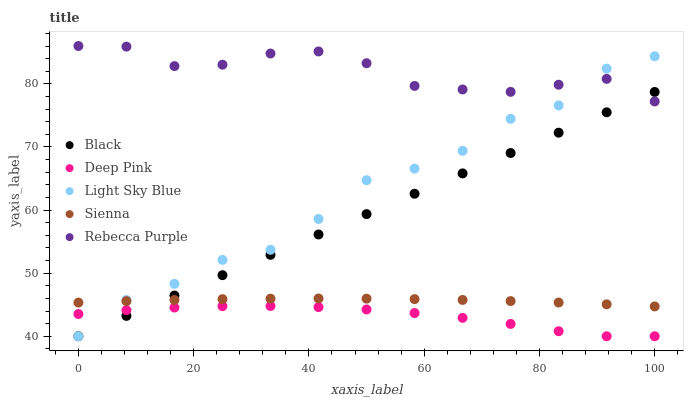Does Deep Pink have the minimum area under the curve?
Answer yes or no. Yes. Does Rebecca Purple have the maximum area under the curve?
Answer yes or no. Yes. Does Black have the minimum area under the curve?
Answer yes or no. No. Does Black have the maximum area under the curve?
Answer yes or no. No. Is Black the smoothest?
Answer yes or no. Yes. Is Light Sky Blue the roughest?
Answer yes or no. Yes. Is Deep Pink the smoothest?
Answer yes or no. No. Is Deep Pink the roughest?
Answer yes or no. No. Does Deep Pink have the lowest value?
Answer yes or no. Yes. Does Rebecca Purple have the lowest value?
Answer yes or no. No. Does Rebecca Purple have the highest value?
Answer yes or no. Yes. Does Black have the highest value?
Answer yes or no. No. Is Deep Pink less than Sienna?
Answer yes or no. Yes. Is Sienna greater than Deep Pink?
Answer yes or no. Yes. Does Light Sky Blue intersect Rebecca Purple?
Answer yes or no. Yes. Is Light Sky Blue less than Rebecca Purple?
Answer yes or no. No. Is Light Sky Blue greater than Rebecca Purple?
Answer yes or no. No. Does Deep Pink intersect Sienna?
Answer yes or no. No. 